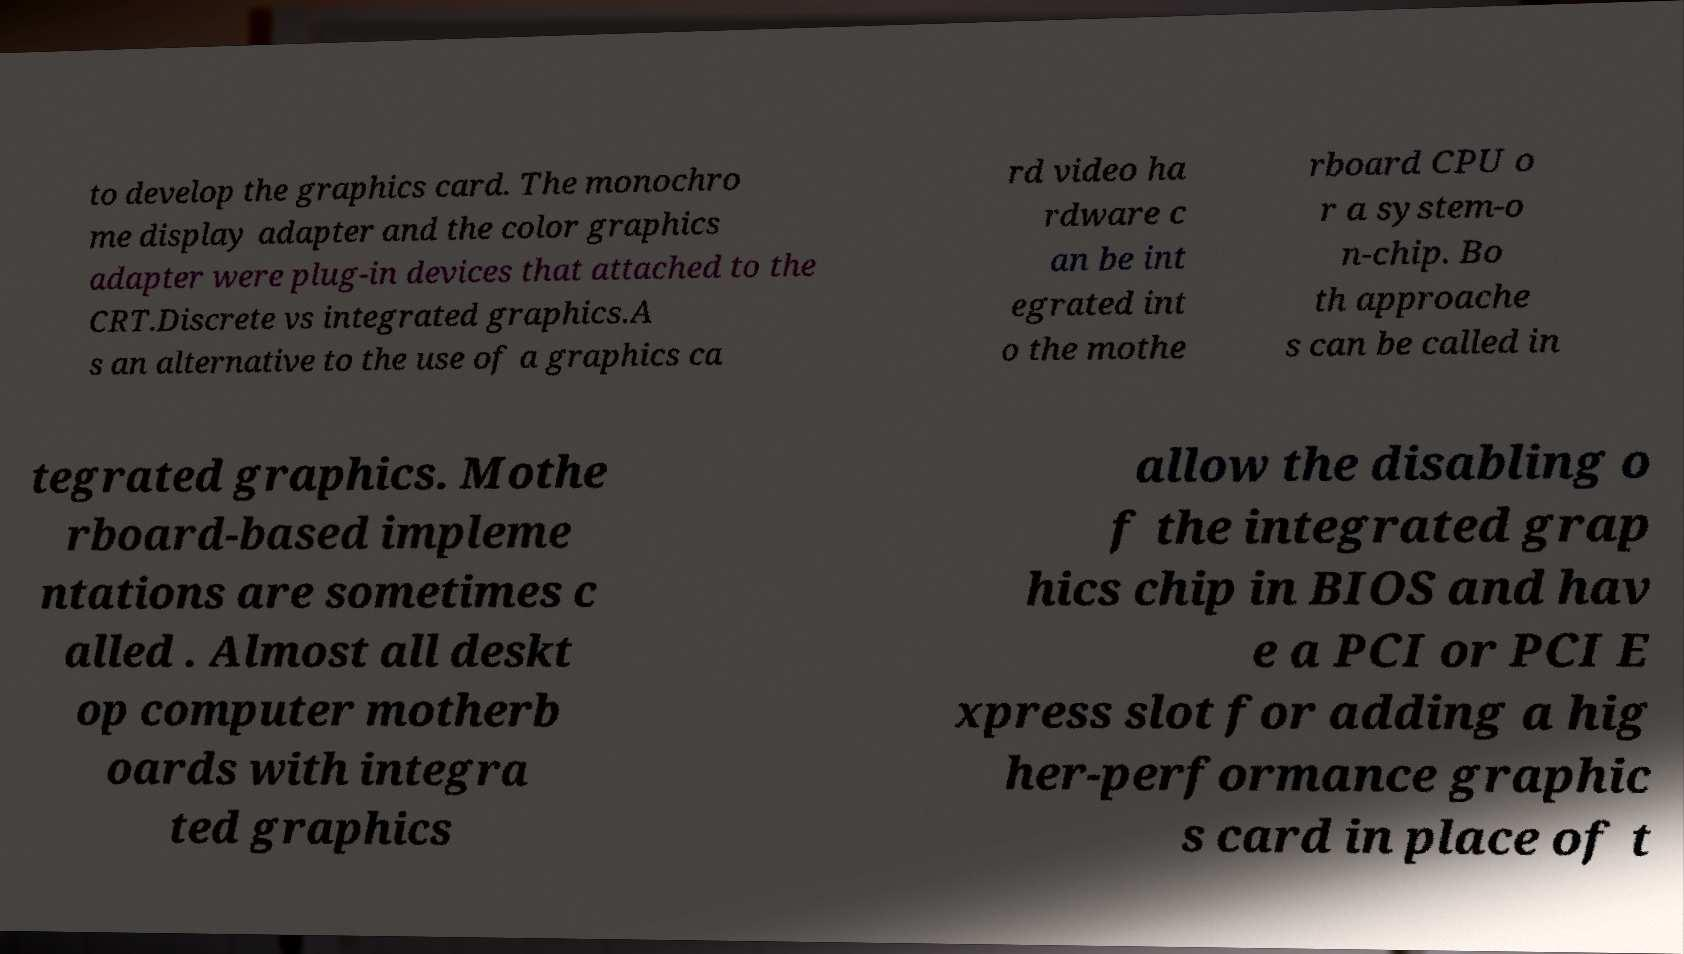I need the written content from this picture converted into text. Can you do that? to develop the graphics card. The monochro me display adapter and the color graphics adapter were plug-in devices that attached to the CRT.Discrete vs integrated graphics.A s an alternative to the use of a graphics ca rd video ha rdware c an be int egrated int o the mothe rboard CPU o r a system-o n-chip. Bo th approache s can be called in tegrated graphics. Mothe rboard-based impleme ntations are sometimes c alled . Almost all deskt op computer motherb oards with integra ted graphics allow the disabling o f the integrated grap hics chip in BIOS and hav e a PCI or PCI E xpress slot for adding a hig her-performance graphic s card in place of t 